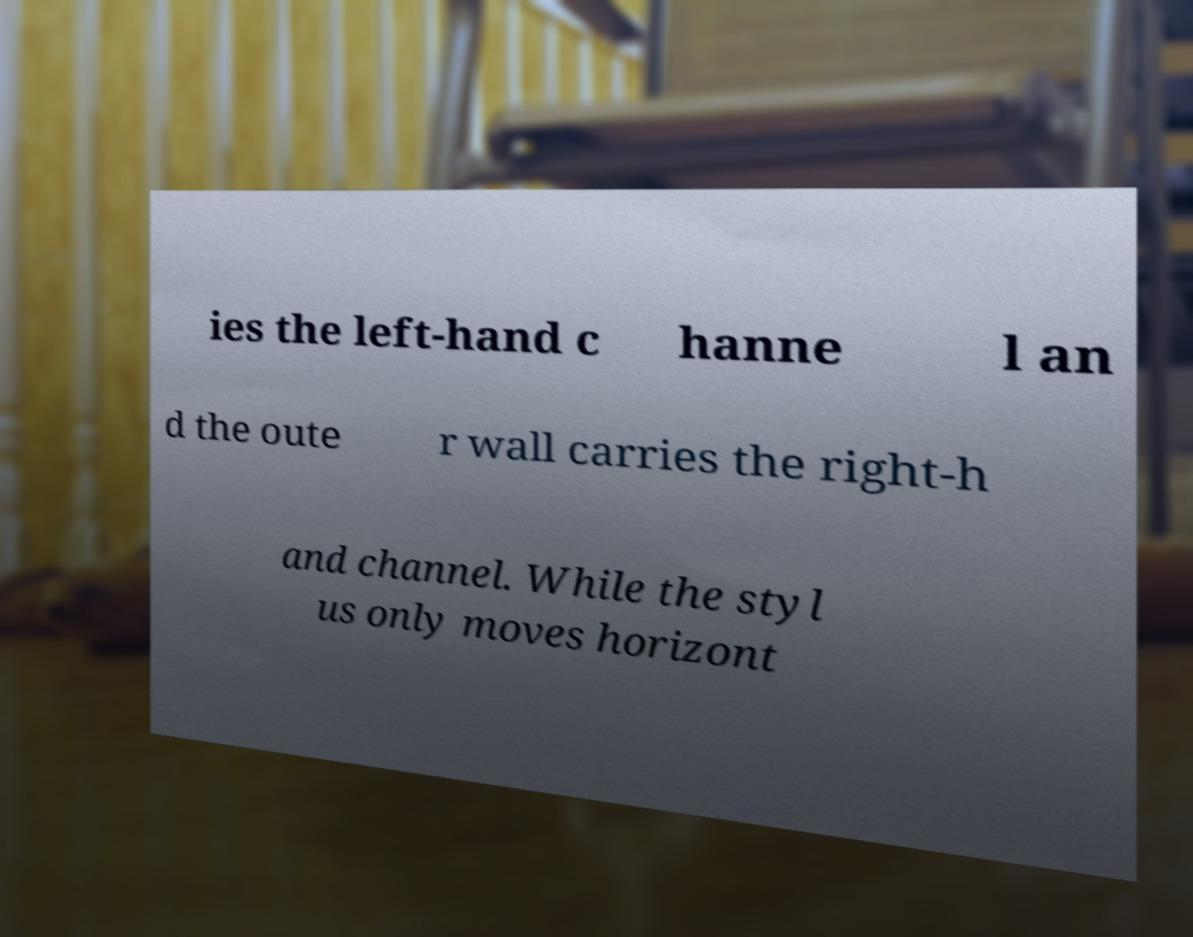What messages or text are displayed in this image? I need them in a readable, typed format. ies the left-hand c hanne l an d the oute r wall carries the right-h and channel. While the styl us only moves horizont 